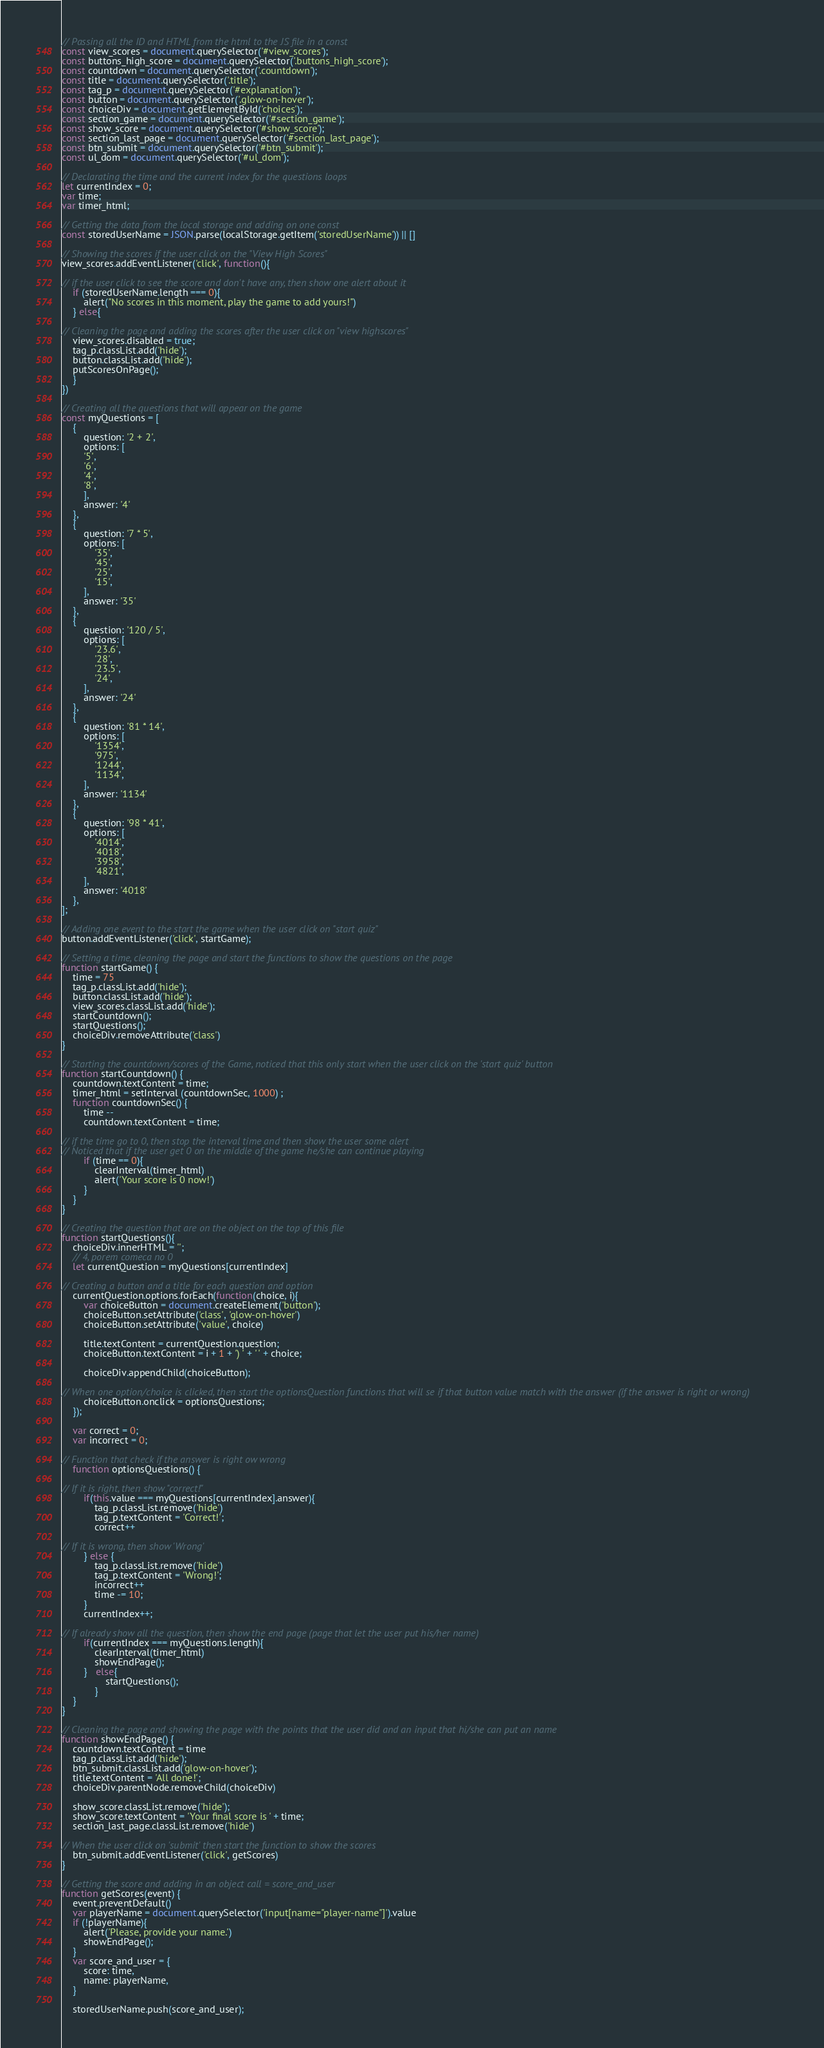Convert code to text. <code><loc_0><loc_0><loc_500><loc_500><_JavaScript_>// Passing all the ID and HTML from the html to the JS file in a const
const view_scores = document.querySelector('#view_scores');
const buttons_high_score = document.querySelector('.buttons_high_score');
const countdown = document.querySelector('.countdown');
const title = document.querySelector('.title');
const tag_p = document.querySelector('#explanation');
const button = document.querySelector('.glow-on-hover');
const choiceDiv = document.getElementById('choices');
const section_game = document.querySelector('#section_game');
const show_score = document.querySelector('#show_score');
const section_last_page = document.querySelector('#section_last_page');
const btn_submit = document.querySelector('#btn_submit');
const ul_dom = document.querySelector('#ul_dom');

// Declarating the time and the current index for the questions loops
let currentIndex = 0;
var time;
var timer_html;

// Getting the data from the local storage and adding on one const
const storedUserName = JSON.parse(localStorage.getItem('storedUserName')) || []

// Showing the scores if the user click on the "View High Scores"
view_scores.addEventListener('click', function(){

// if the user click to see the score and don't have any, then show one alert about it
    if (storedUserName.length === 0){
        alert("No scores in this moment, play the game to add yours!")
    } else{

// Cleaning the page and adding the scores after the user click on "view highscores"
    view_scores.disabled = true;
    tag_p.classList.add('hide');
    button.classList.add('hide');
    putScoresOnPage();
    }
})

// Creating all the questions that will appear on the game
const myQuestions = [
    {
        question: '2 + 2',
        options: [
        '5',
        '6',
        '4',
        '8',
        ],
        answer: '4'
    },
    {
        question: '7 * 5',
        options: [
            '35', 
            '45',
            '25',
            '15',
        ],
        answer: '35'
    },
    {
        question: '120 / 5',
        options: [
            '23.6',
            '28',
            '23.5',
            '24',
        ],
        answer: '24'
    },
    {
        question: '81 * 14',
        options: [
            '1354',
            '975',
            '1244',
            '1134',
        ],
        answer: '1134'
    },
    {
        question: '98 * 41',
        options: [
            '4014',
            '4018',
            '3958',
            '4821',
        ],
        answer: '4018'
    },
];

// Adding one event to the start the game when the user click on "start quiz"
button.addEventListener('click', startGame);

// Setting a time, cleaning the page and start the functions to show the questions on the page
function startGame() {
    time = 75
    tag_p.classList.add('hide');
    button.classList.add('hide');
    view_scores.classList.add('hide');
    startCountdown();
    startQuestions();
    choiceDiv.removeAttribute('class')
}

// Starting the countdown/scores of the Game, noticed that this only start when the user click on the 'start quiz' button
function startCountdown() {
    countdown.textContent = time;
    timer_html = setInterval (countdownSec, 1000) ;
    function countdownSec() {
        time --
        countdown.textContent = time;

// if the time go to 0, then stop the interval time and then show the user some alert
// Noticed that if the user get 0 on the middle of the game he/she can continue playing
        if (time == 0){
            clearInterval(timer_html)
            alert('Your score is 0 now!')
        }
    }
}

// Creating the question that are on the object on the top of this file
function startQuestions(){
    choiceDiv.innerHTML = '';
    // 4, porem comeca no 0
    let currentQuestion = myQuestions[currentIndex]

// Creating a button and a title for each question and option
    currentQuestion.options.forEach(function(choice, i){
        var choiceButton = document.createElement('button');
        choiceButton.setAttribute('class', 'glow-on-hover')
        choiceButton.setAttribute('value', choice)

        title.textContent = currentQuestion.question;
        choiceButton.textContent = i + 1 + ') ' + ' ' + choice;

        choiceDiv.appendChild(choiceButton);

// When one option/choice is clicked, then start the optionsQuestion functions that will se if that button value match with the answer (if the answer is right or wrong)
        choiceButton.onclick = optionsQuestions;
    });

    var correct = 0;
    var incorrect = 0;

// Function that check if the answer is right ow wrong
    function optionsQuestions() {

// If it is right, then show "correct!"
        if(this.value === myQuestions[currentIndex].answer){
            tag_p.classList.remove('hide')
            tag_p.textContent = 'Correct!';
            correct++

// If it is wrong, then show 'Wrong'
        } else {
            tag_p.classList.remove('hide')
            tag_p.textContent = 'Wrong!';
            incorrect++
            time -= 10;
        }
        currentIndex++;

// If already show all the question, then show the end page (page that let the user put his/her name)
        if(currentIndex === myQuestions.length){
            clearInterval(timer_html)
            showEndPage();  
        }   else{
                startQuestions();
            }
    }
}

// Cleaning the page and showing the page with the points that the user did and an input that hi/she can put an name
function showEndPage() {
    countdown.textContent = time
    tag_p.classList.add('hide');
    btn_submit.classList.add('glow-on-hover');
    title.textContent = 'All done!';
    choiceDiv.parentNode.removeChild(choiceDiv)

    show_score.classList.remove('hide');
    show_score.textContent = 'Your final score is ' + time;
    section_last_page.classList.remove('hide')

// When the user click on 'submit' then start the function to show the scores
    btn_submit.addEventListener('click', getScores)
}

// Getting the score and adding in an object call = score_and_user
function getScores(event) {
    event.preventDefault()
    var playerName = document.querySelector('input[name="player-name"]').value
    if (!playerName){
        alert('Please, provide your name.')
        showEndPage();
    }
    var score_and_user = {
        score: time,
        name: playerName,
    }

    storedUserName.push(score_and_user);</code> 